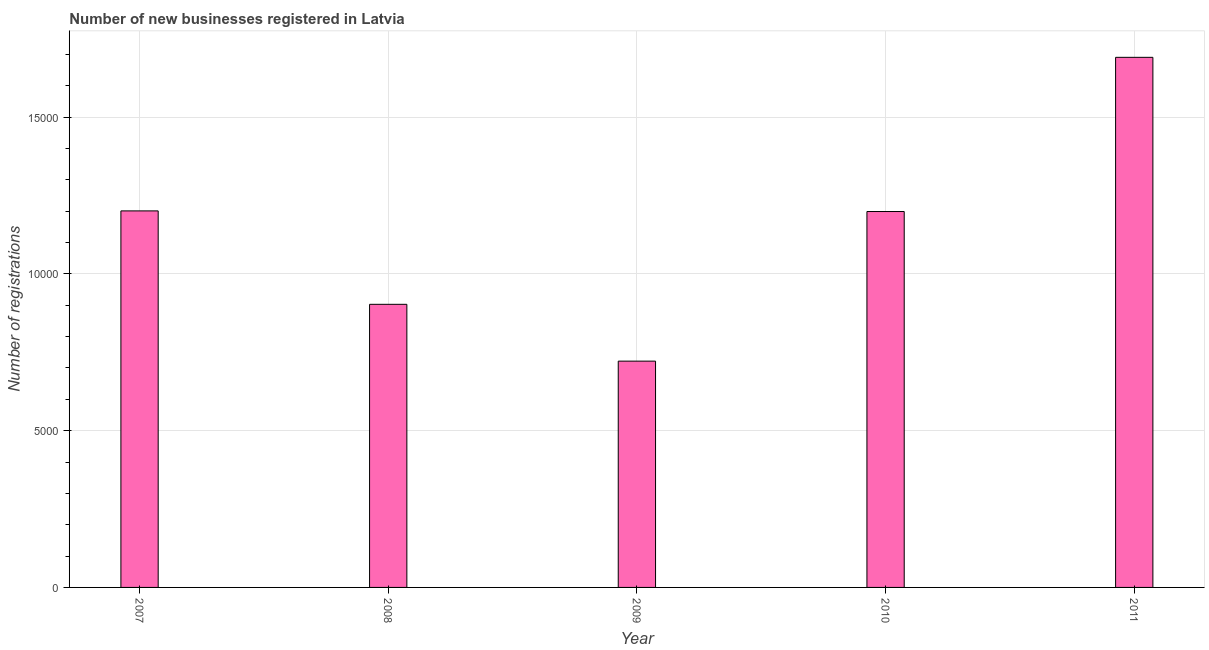Does the graph contain any zero values?
Provide a succinct answer. No. Does the graph contain grids?
Your response must be concise. Yes. What is the title of the graph?
Give a very brief answer. Number of new businesses registered in Latvia. What is the label or title of the Y-axis?
Ensure brevity in your answer.  Number of registrations. What is the number of new business registrations in 2011?
Ensure brevity in your answer.  1.69e+04. Across all years, what is the maximum number of new business registrations?
Make the answer very short. 1.69e+04. Across all years, what is the minimum number of new business registrations?
Keep it short and to the point. 7218. In which year was the number of new business registrations maximum?
Ensure brevity in your answer.  2011. In which year was the number of new business registrations minimum?
Offer a terse response. 2009. What is the sum of the number of new business registrations?
Your answer should be compact. 5.72e+04. What is the difference between the number of new business registrations in 2008 and 2010?
Your answer should be very brief. -2960. What is the average number of new business registrations per year?
Your answer should be very brief. 1.14e+04. What is the median number of new business registrations?
Ensure brevity in your answer.  1.20e+04. In how many years, is the number of new business registrations greater than 9000 ?
Your response must be concise. 4. Do a majority of the years between 2011 and 2010 (inclusive) have number of new business registrations greater than 6000 ?
Offer a terse response. No. What is the ratio of the number of new business registrations in 2008 to that in 2010?
Offer a very short reply. 0.75. Is the difference between the number of new business registrations in 2007 and 2011 greater than the difference between any two years?
Offer a terse response. No. What is the difference between the highest and the second highest number of new business registrations?
Offer a terse response. 4898. What is the difference between the highest and the lowest number of new business registrations?
Provide a short and direct response. 9690. In how many years, is the number of new business registrations greater than the average number of new business registrations taken over all years?
Ensure brevity in your answer.  3. How many bars are there?
Your answer should be compact. 5. Are all the bars in the graph horizontal?
Your answer should be compact. No. How many years are there in the graph?
Provide a succinct answer. 5. What is the difference between two consecutive major ticks on the Y-axis?
Ensure brevity in your answer.  5000. What is the Number of registrations in 2007?
Ensure brevity in your answer.  1.20e+04. What is the Number of registrations in 2008?
Provide a short and direct response. 9030. What is the Number of registrations of 2009?
Give a very brief answer. 7218. What is the Number of registrations of 2010?
Your response must be concise. 1.20e+04. What is the Number of registrations in 2011?
Your answer should be compact. 1.69e+04. What is the difference between the Number of registrations in 2007 and 2008?
Offer a terse response. 2980. What is the difference between the Number of registrations in 2007 and 2009?
Make the answer very short. 4792. What is the difference between the Number of registrations in 2007 and 2010?
Your response must be concise. 20. What is the difference between the Number of registrations in 2007 and 2011?
Offer a very short reply. -4898. What is the difference between the Number of registrations in 2008 and 2009?
Give a very brief answer. 1812. What is the difference between the Number of registrations in 2008 and 2010?
Your answer should be very brief. -2960. What is the difference between the Number of registrations in 2008 and 2011?
Ensure brevity in your answer.  -7878. What is the difference between the Number of registrations in 2009 and 2010?
Your answer should be compact. -4772. What is the difference between the Number of registrations in 2009 and 2011?
Make the answer very short. -9690. What is the difference between the Number of registrations in 2010 and 2011?
Your answer should be compact. -4918. What is the ratio of the Number of registrations in 2007 to that in 2008?
Your answer should be compact. 1.33. What is the ratio of the Number of registrations in 2007 to that in 2009?
Give a very brief answer. 1.66. What is the ratio of the Number of registrations in 2007 to that in 2010?
Give a very brief answer. 1. What is the ratio of the Number of registrations in 2007 to that in 2011?
Your answer should be compact. 0.71. What is the ratio of the Number of registrations in 2008 to that in 2009?
Provide a short and direct response. 1.25. What is the ratio of the Number of registrations in 2008 to that in 2010?
Offer a very short reply. 0.75. What is the ratio of the Number of registrations in 2008 to that in 2011?
Give a very brief answer. 0.53. What is the ratio of the Number of registrations in 2009 to that in 2010?
Ensure brevity in your answer.  0.6. What is the ratio of the Number of registrations in 2009 to that in 2011?
Your answer should be compact. 0.43. What is the ratio of the Number of registrations in 2010 to that in 2011?
Your answer should be very brief. 0.71. 